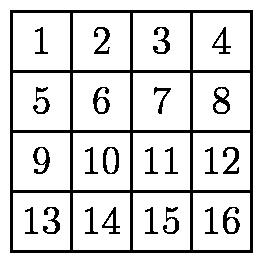How symmetrical is the arrangement of numbers in the diagram, considering the folding instructions? The diagram shows a clear symmetrical arrangement in a 4x4 grid which aids in executing the folding instructions methodically. Each fold divides the grid into equal halves, maintaining the symmetry essential for predictable results after each fold. This symmetry ensures that each portion of the paper is evenly divided, leading to a systematic and uniform final folded paper. 